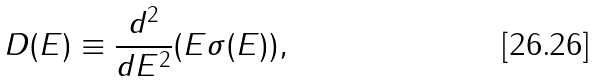Convert formula to latex. <formula><loc_0><loc_0><loc_500><loc_500>D ( E ) \equiv \frac { d ^ { 2 } } { d E ^ { 2 } } ( E \sigma ( E ) ) ,</formula> 